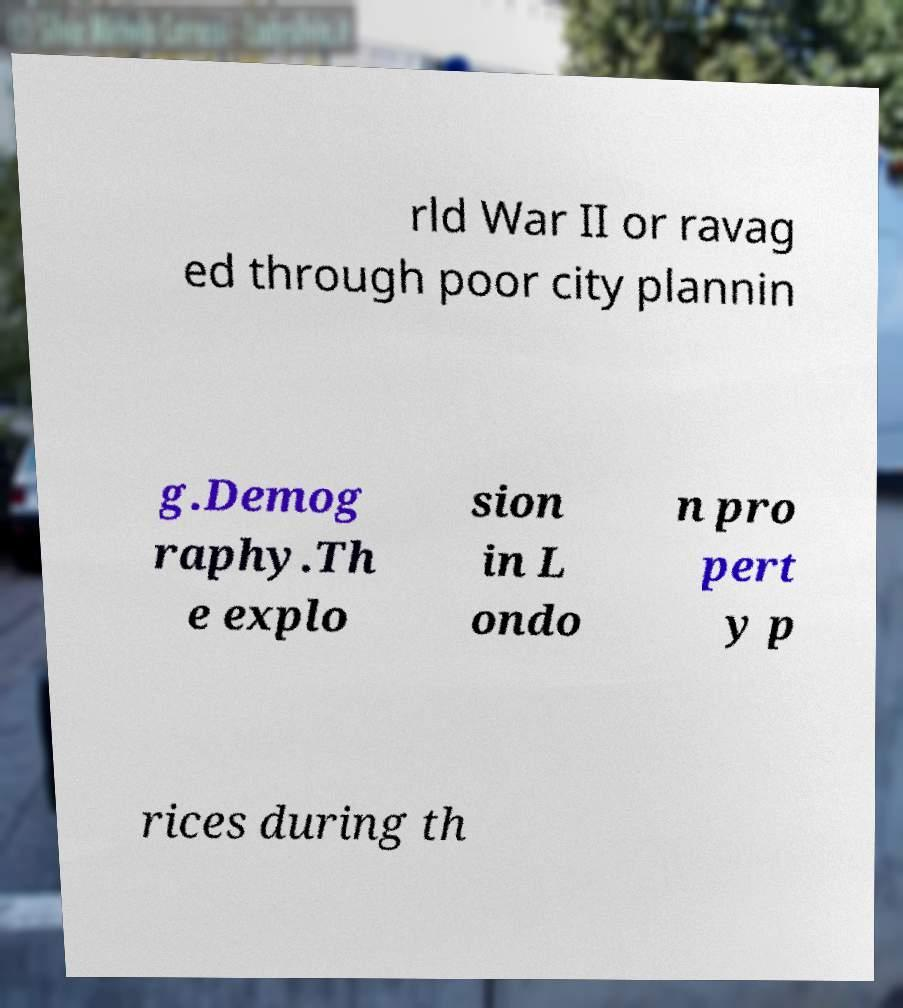Could you assist in decoding the text presented in this image and type it out clearly? rld War II or ravag ed through poor city plannin g.Demog raphy.Th e explo sion in L ondo n pro pert y p rices during th 